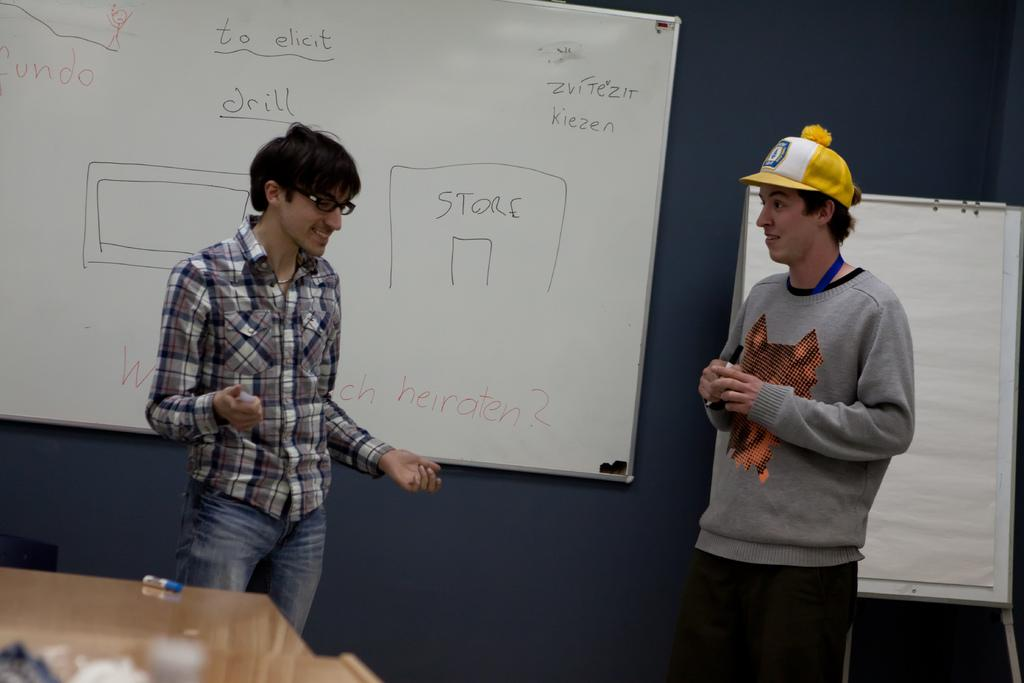<image>
Give a short and clear explanation of the subsequent image. Two students give a presentation in front of a dry erase board with a Store drawn on it. 